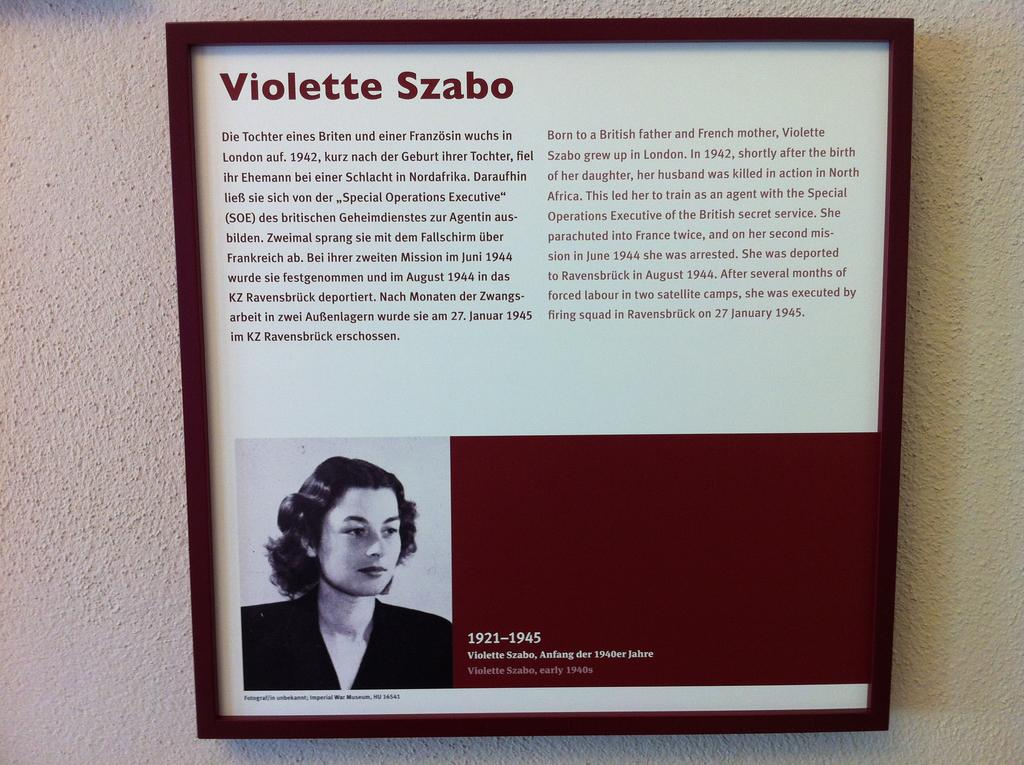What is attached to the pole in the image? There is a frame attached to a pole in the image. What is depicted within the frame? The frame contains a picture of a person. Are there any words or phrases in the frame? Yes, there is some text present in the frame. What type of dress is the person wearing in the image? There is no dress visible in the image, as the person is depicted in a picture within a frame. How much current is flowing through the frame in the image? There is no information about electrical current in the image, as it only features a frame with a picture and text. 